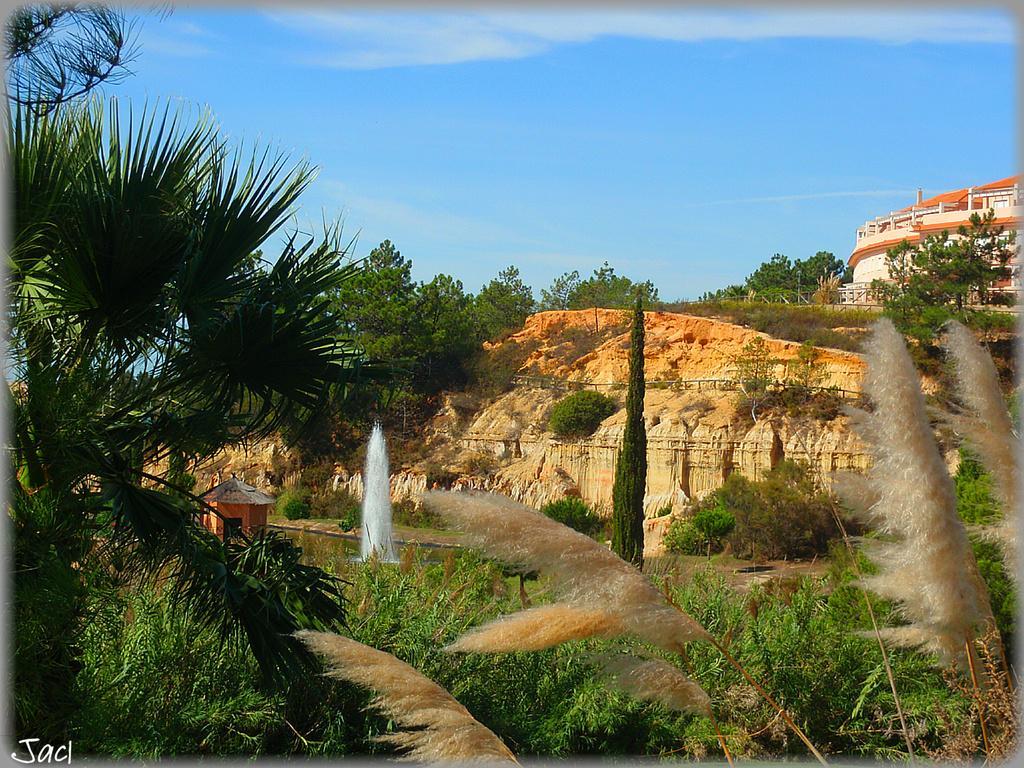Can you describe this image briefly? In this image there are trees on the left corner. There are trees, there is a building on the right corner. There is a water fountain, there are trees in the foreground. There are rocks and trees in the background. There is sky at the top. 